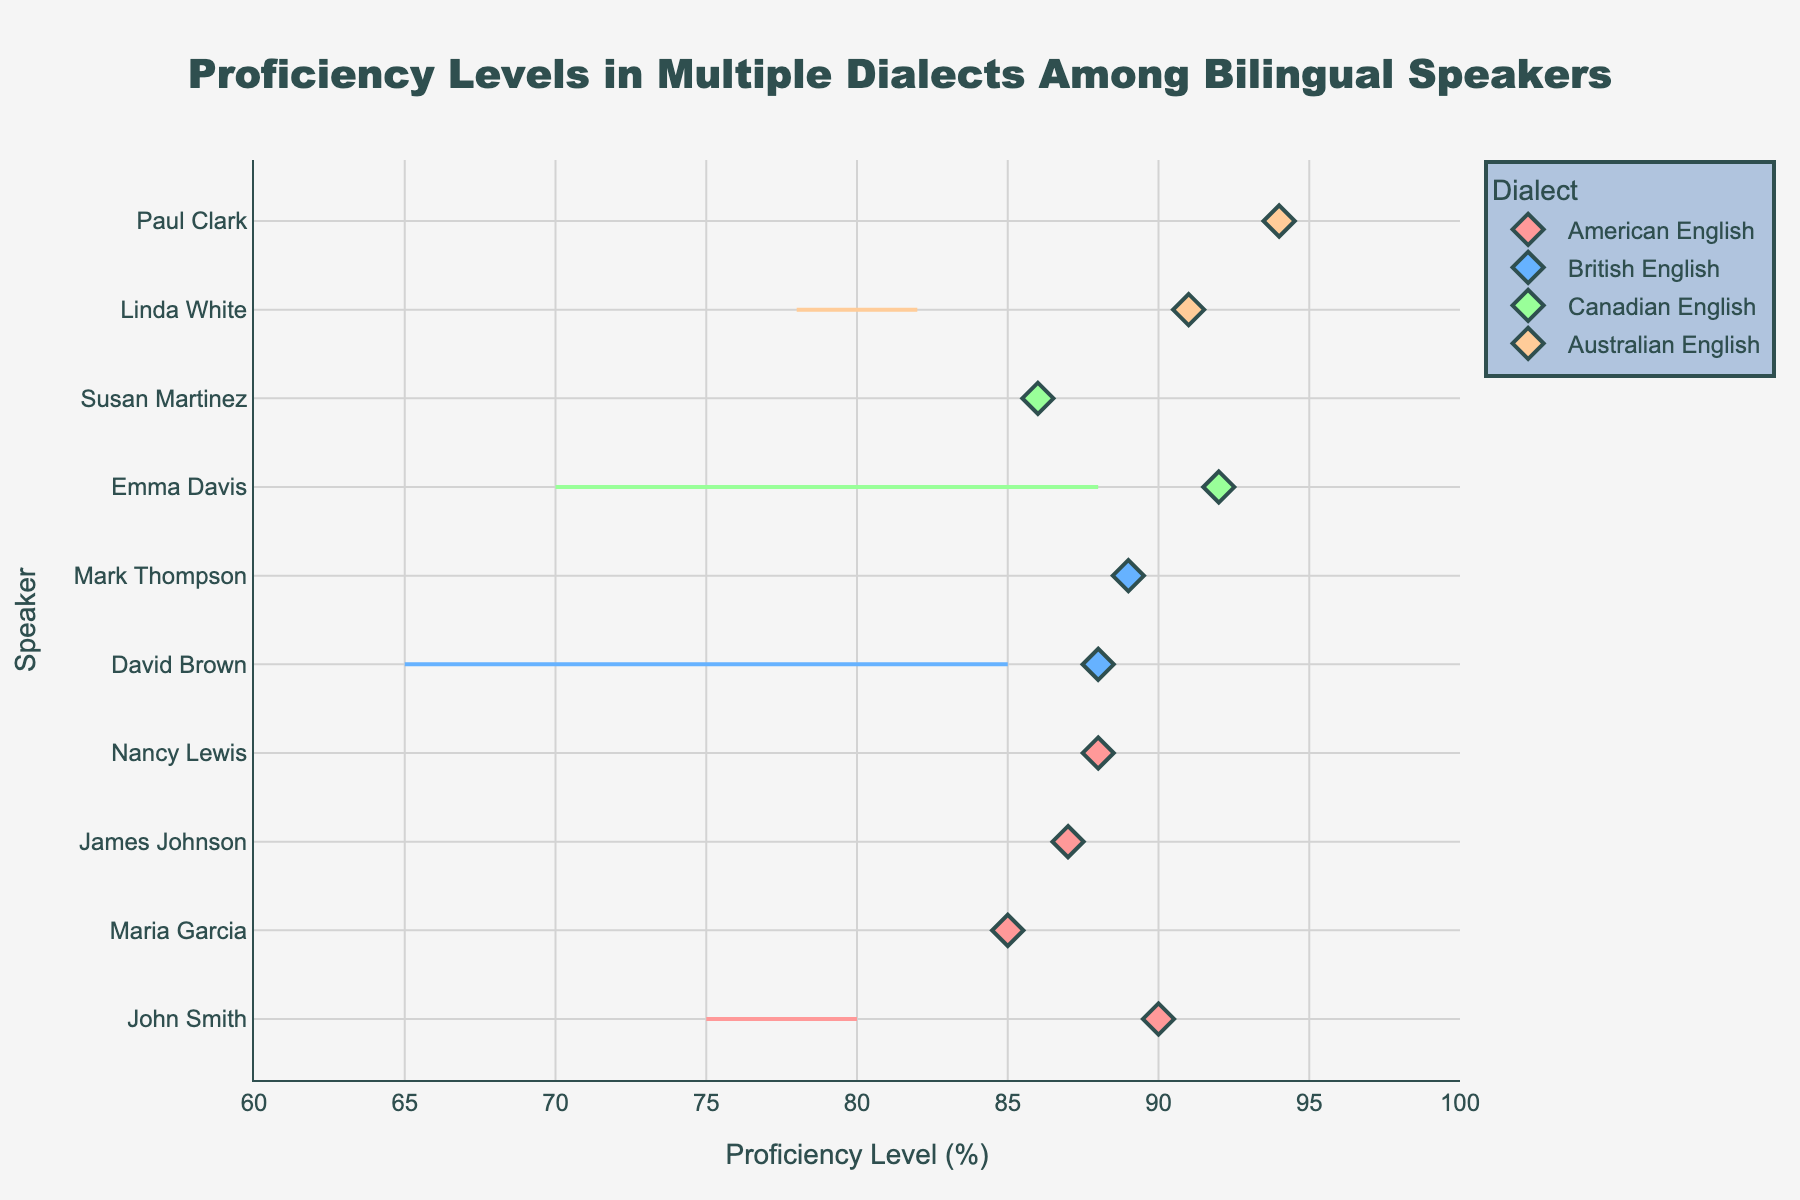How many different dialects are represented in the plot? There are colors representing each dialect in the legend. Counting them gives us: American English, British English, Canadian English, and Australian English.
Answer: 4 Which speaker has the highest standardized proficiency level? The speaker with the highest value on the x-axis (standardized proficiency) is Paul Clark with a score of 94.
Answer: Paul Clark What is the proficiency range for John Smith in American English? John Smith's proficiency levels for Dialect 1 and Dialect 2 are given in the hovertext. The range is from 75% to 80%.
Answer: 75% to 80% What is the average proficiency level in Dialect 1 for speakers of British English? For British English, the proficiency levels in Dialect 1 are 85 and 80. The average is (85 + 80)/2 = 82.5%.
Answer: 82.5% Which dialect shows the smallest difference between proficiency levels in Dialect 1 and Dialect 2? Comparing the differences for each unique dialect: American English (80-75, 70-80, 75-85, 81-83), British English (85-65, 80-72), Canadian English (88-70, 79-77), and Australian English (82-78, 86-80). The smallest differences are in Canadian English, with Susan Martinez having a 2% difference.
Answer: Canadian English Who are the speakers with a standardized proficiency level above 90%? The speakers with values over 90 on the x-axis are Emma Davis (92), Linda White (91), and Paul Clark (94).
Answer: Emma Davis, Linda White, Paul Clark Which speaker has the largest discrepancy between Dialect 1 and Dialect 2 proficiency levels? Looking at the hovertext, for David Brown (British English), the difference between 85 and 65 is the largest at 20%.
Answer: David Brown What's the title of the plot? The title is located at the top center of the plot and reads: 'Proficiency Levels in Multiple Dialects Among Bilingual Speakers.'
Answer: Proficiency Levels in Multiple Dialects Among Bilingual Speakers Which speaker has the lowest proficiency level in Dialect 2? Checking the hovertext for the lowest value in Dialect 2 across all speakers, David Brown (British English) has a proficiency level of 65%.
Answer: David Brown Between American and Australian English, which has higher average proficiency levels in Dialect 1? For American English: (80, 70, 75, 75, 81) gives an average of 76.2. For Australian English: (82, 86) gives an average of 84. Australian English has a higher average.
Answer: Australian English 